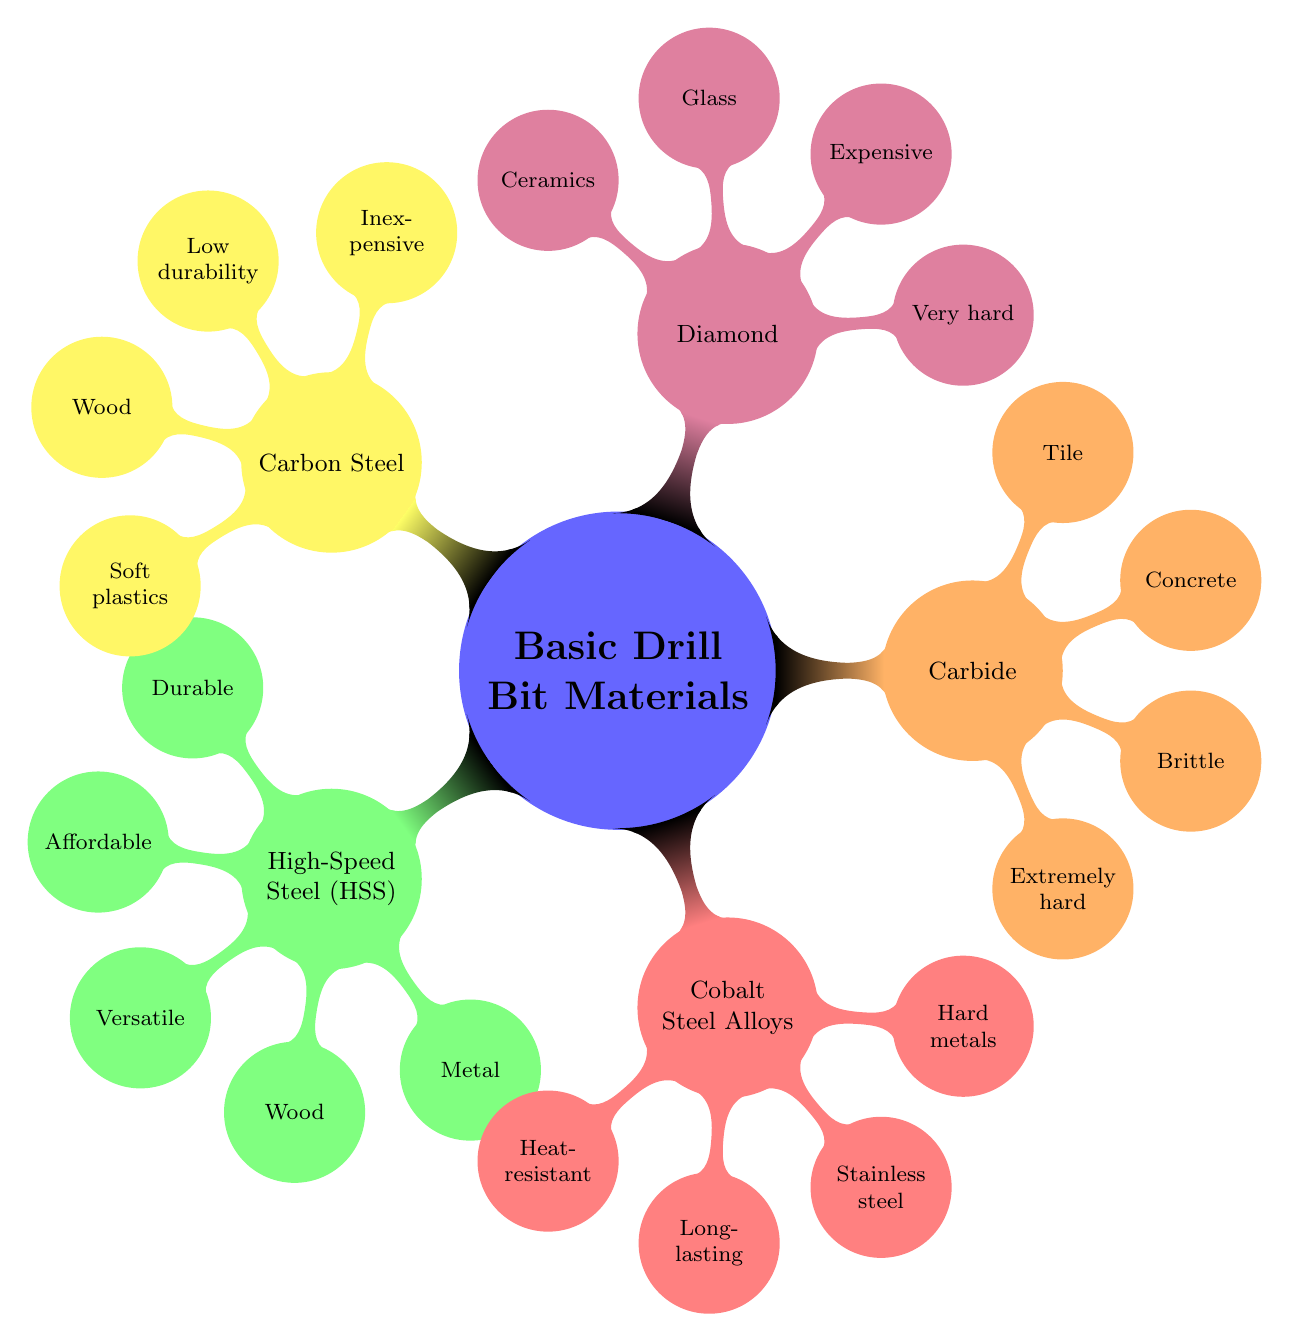What are the properties of High-Speed Steel? The diagram lists the properties of High-Speed Steel as "Durable," "Affordable," and "Versatile." This information is directly visible under the "High-Speed Steel (HSS)" node.
Answer: Durable, Affordable, Versatile Which material is best for drilling concrete? The diagram shows that "Carbide" is best for "Concrete." This is located under the "Carbide" node where it lists the best materials for different uses.
Answer: Carbide How many properties does Carbon Steel have listed? Under "Carbon Steel," there are two properties listed: "Inexpensive" and "Low durability." The diagram clearly shows these two properties as branches from the "Carbon Steel" node.
Answer: 2 What is the best material for stainless steel? The diagram indicates that "Cobalt Steel Alloys" are the best for "Stainless steel." This is found in the sub-nodes of the "Cobalt Steel Alloys" node, where it defines the best usage.
Answer: Cobalt Steel Alloys Which is more expensive, Diamond or Carbon Steel? The diagram shows "Diamond" listed as "Expensive," whereas "Carbon Steel" is not described as expensive, indicating a lower price. Therefore, by comparison, Diamond is more expensive.
Answer: Diamond 